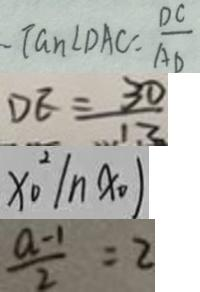<formula> <loc_0><loc_0><loc_500><loc_500>\tan \angle D A C = \frac { D C } { A D } 
 D E = \frac { 3 0 } { 1 3 } 
 x _ { 0 } ^ { 2 } \vert n x _ { 0 } ) 
 \frac { a - 1 } { 2 } = 2</formula> 